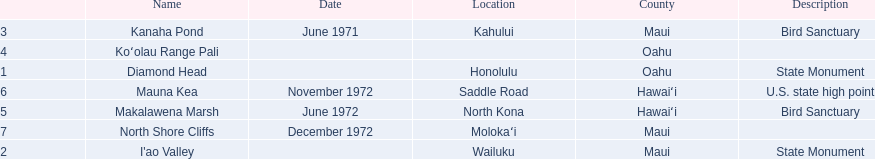What are the total number of landmarks located in maui? 3. 